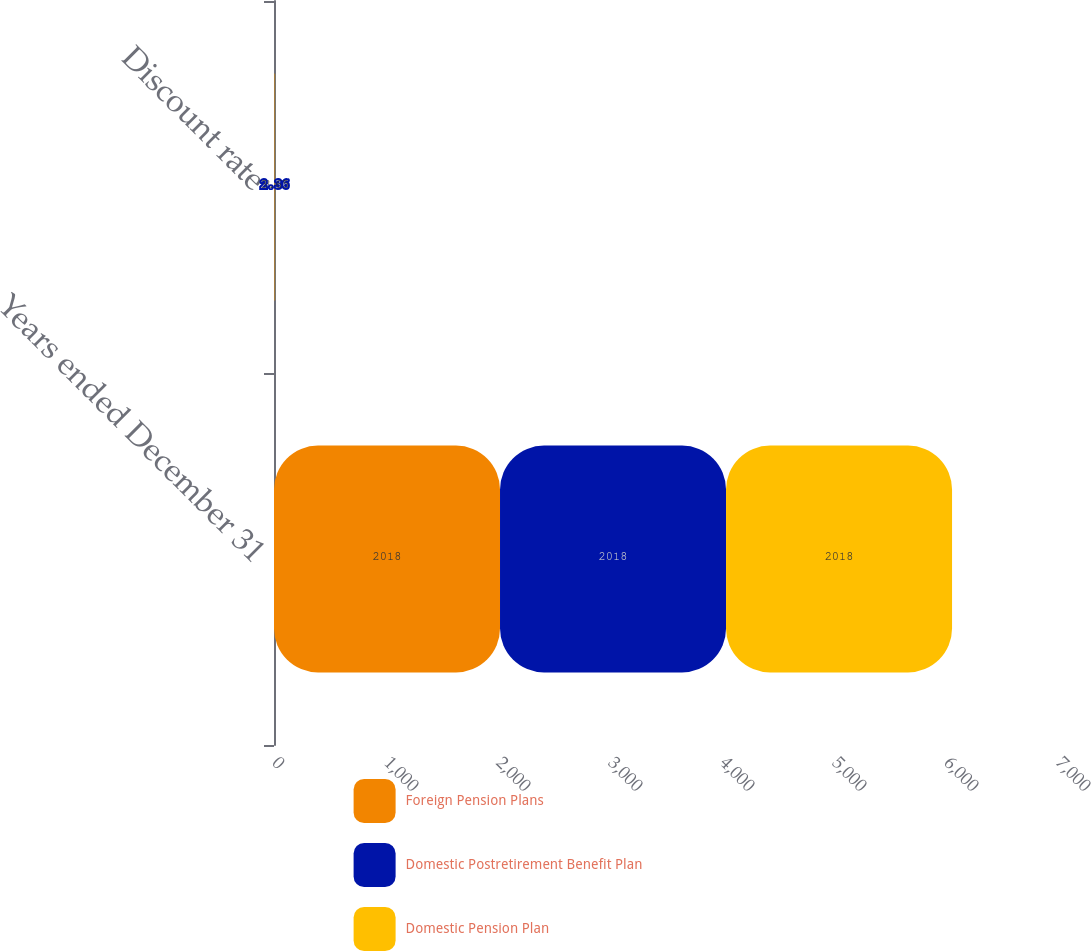Convert chart. <chart><loc_0><loc_0><loc_500><loc_500><stacked_bar_chart><ecel><fcel>Years ended December 31<fcel>Discount rate<nl><fcel>Foreign Pension Plans<fcel>2018<fcel>3.7<nl><fcel>Domestic Postretirement Benefit Plan<fcel>2018<fcel>2.36<nl><fcel>Domestic Pension Plan<fcel>2018<fcel>3.65<nl></chart> 